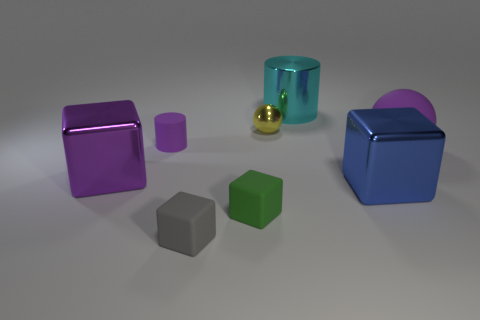How does the lighting in the image affect the mood of the scene? The soft, diffused lighting in the scene casts gentle shadows and creates a calm, almost contemplative mood, emphasizing the simplicity and beauty of the shapes. 